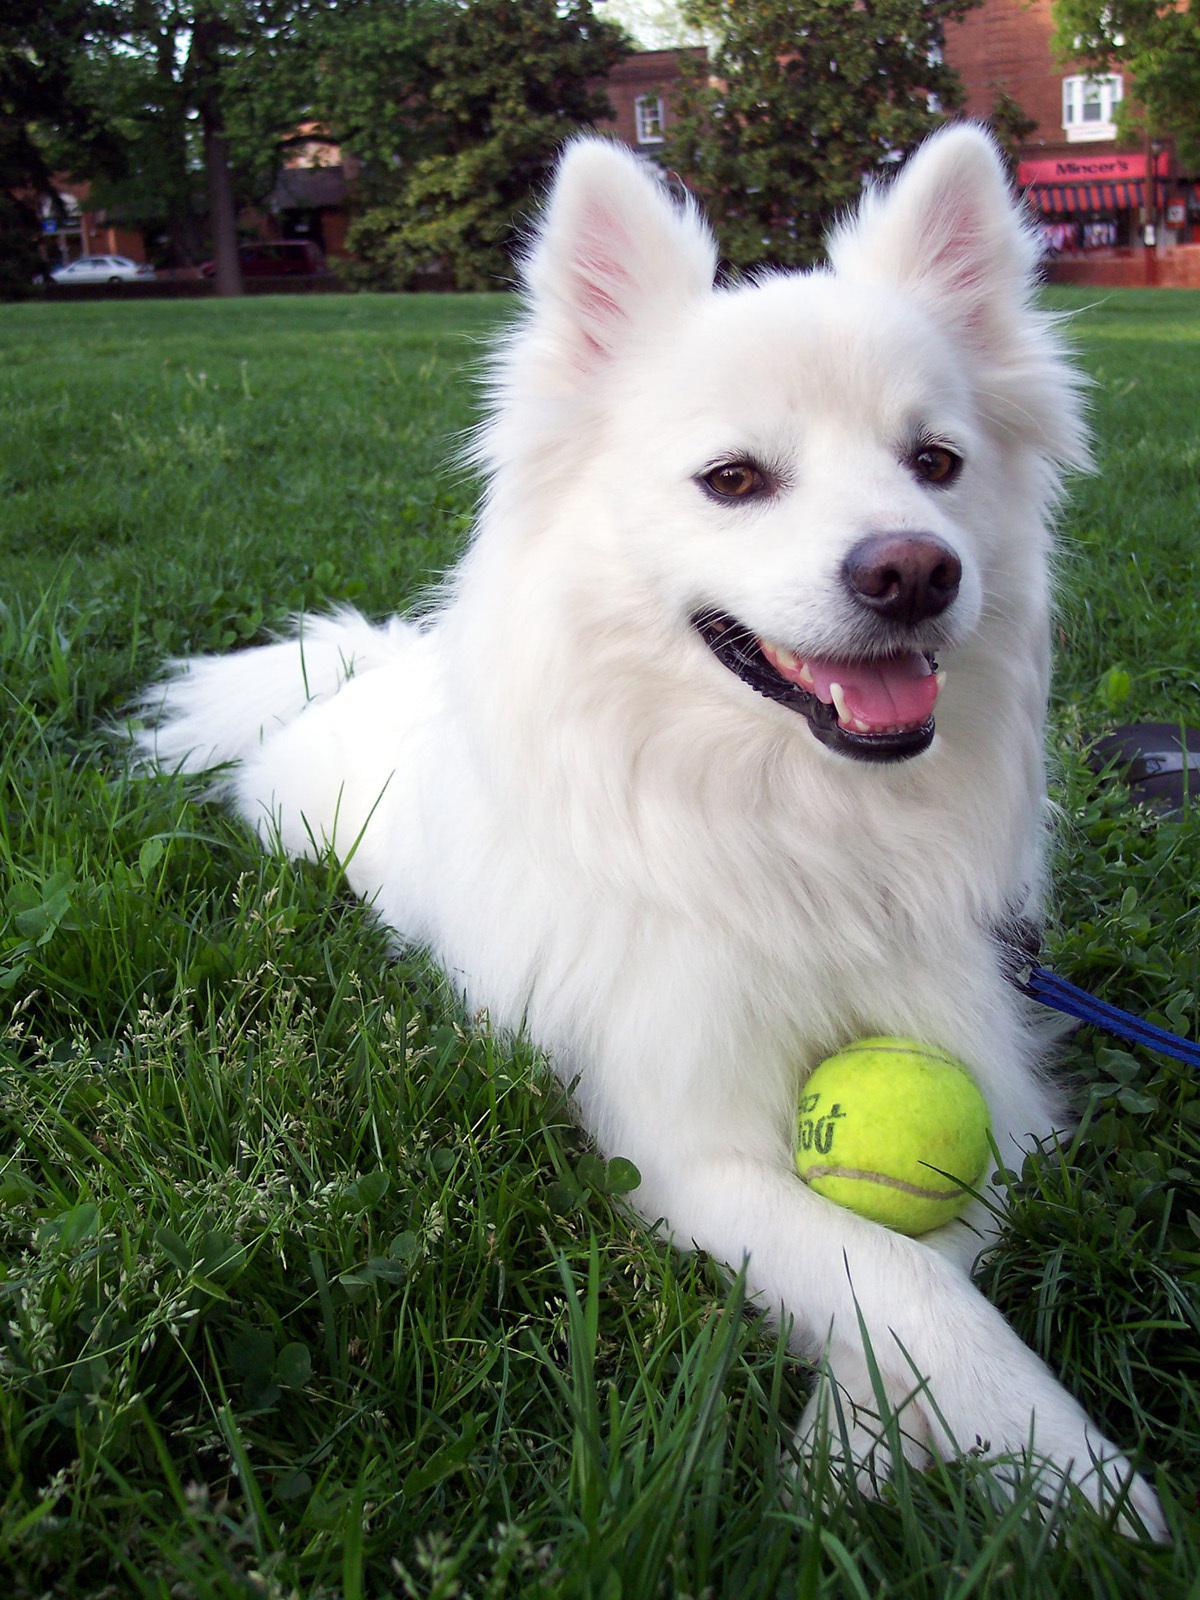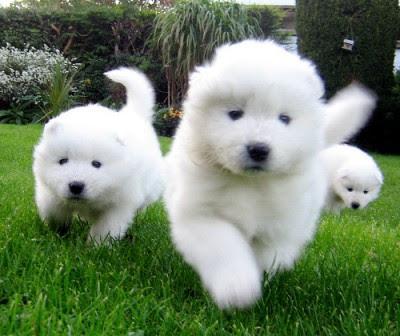The first image is the image on the left, the second image is the image on the right. For the images shown, is this caption "There is an adult dog and a puppy in the left image." true? Answer yes or no. No. 